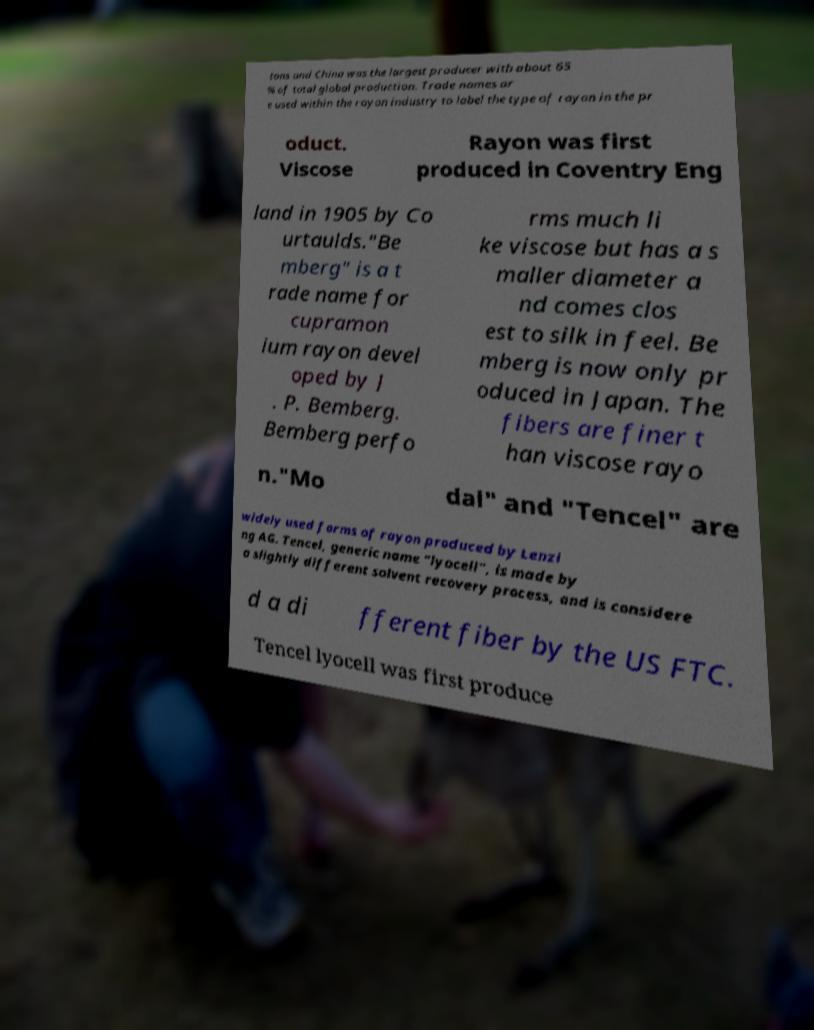What messages or text are displayed in this image? I need them in a readable, typed format. tons and China was the largest producer with about 65 % of total global production. Trade names ar e used within the rayon industry to label the type of rayon in the pr oduct. Viscose Rayon was first produced in Coventry Eng land in 1905 by Co urtaulds."Be mberg" is a t rade name for cupramon ium rayon devel oped by J . P. Bemberg. Bemberg perfo rms much li ke viscose but has a s maller diameter a nd comes clos est to silk in feel. Be mberg is now only pr oduced in Japan. The fibers are finer t han viscose rayo n."Mo dal" and "Tencel" are widely used forms of rayon produced by Lenzi ng AG. Tencel, generic name "lyocell", is made by a slightly different solvent recovery process, and is considere d a di fferent fiber by the US FTC. Tencel lyocell was first produce 